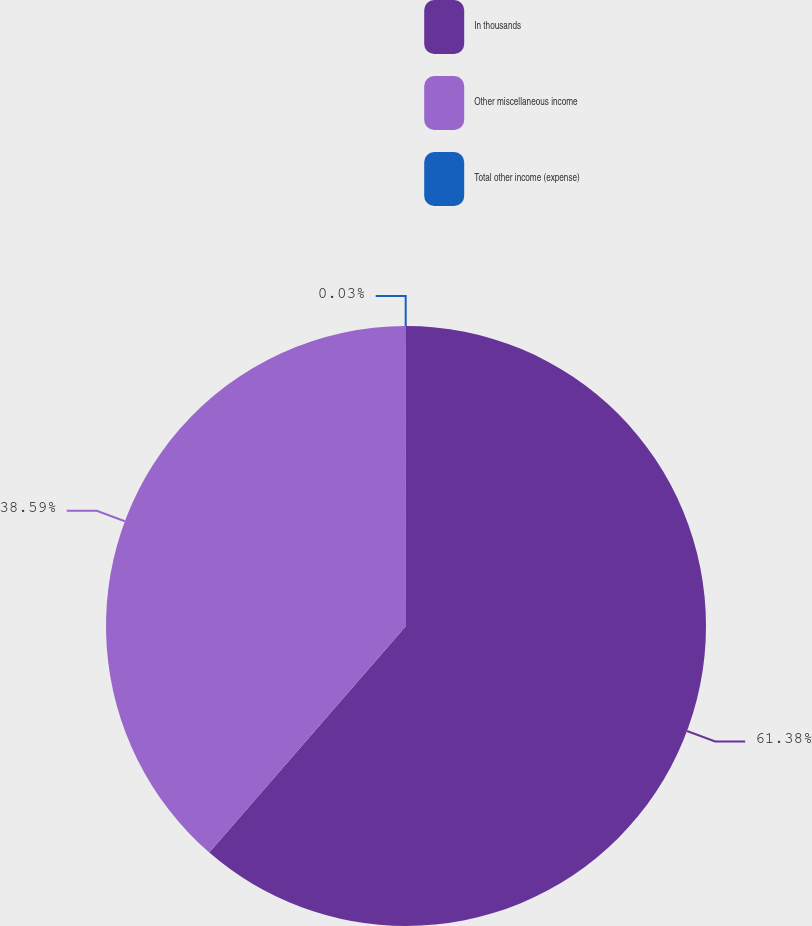Convert chart to OTSL. <chart><loc_0><loc_0><loc_500><loc_500><pie_chart><fcel>In thousands<fcel>Other miscellaneous income<fcel>Total other income (expense)<nl><fcel>61.38%<fcel>38.59%<fcel>0.03%<nl></chart> 